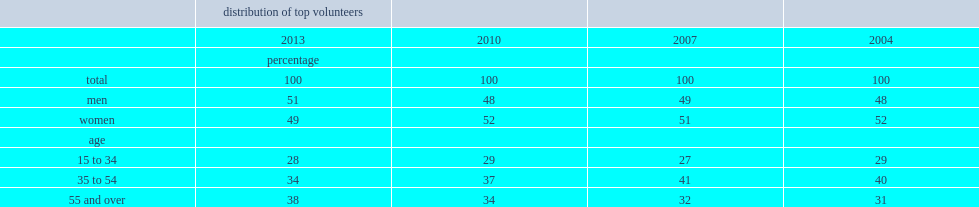What was the percentage of older canadians aged 55 and over represented of these top volunteers in 2013? 38.0. What was the percentage of older canadians aged 55 and over represented of these top volunteers in 2004? 31.0. 